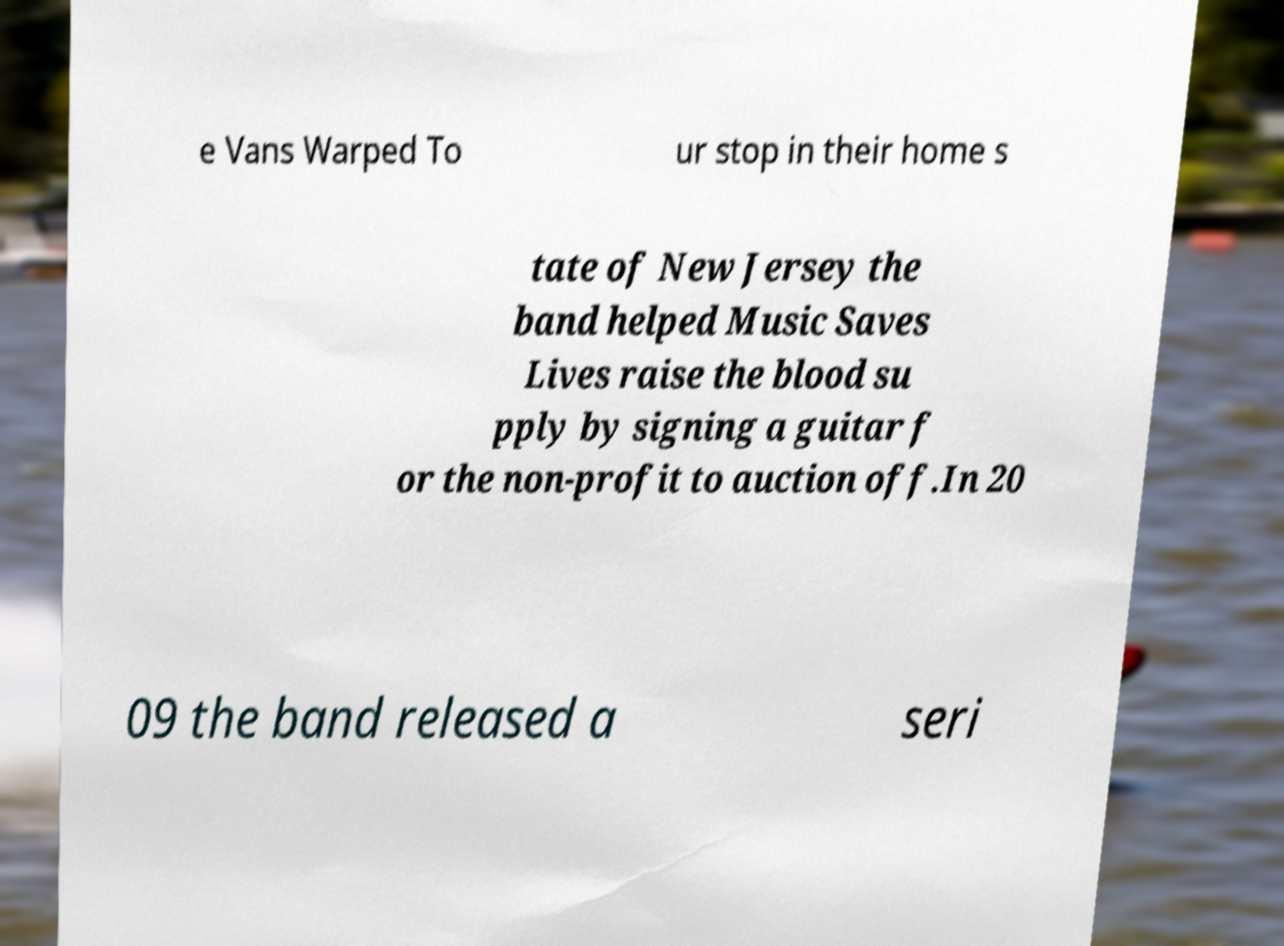Please read and relay the text visible in this image. What does it say? e Vans Warped To ur stop in their home s tate of New Jersey the band helped Music Saves Lives raise the blood su pply by signing a guitar f or the non-profit to auction off.In 20 09 the band released a seri 